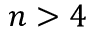Convert formula to latex. <formula><loc_0><loc_0><loc_500><loc_500>n > 4</formula> 